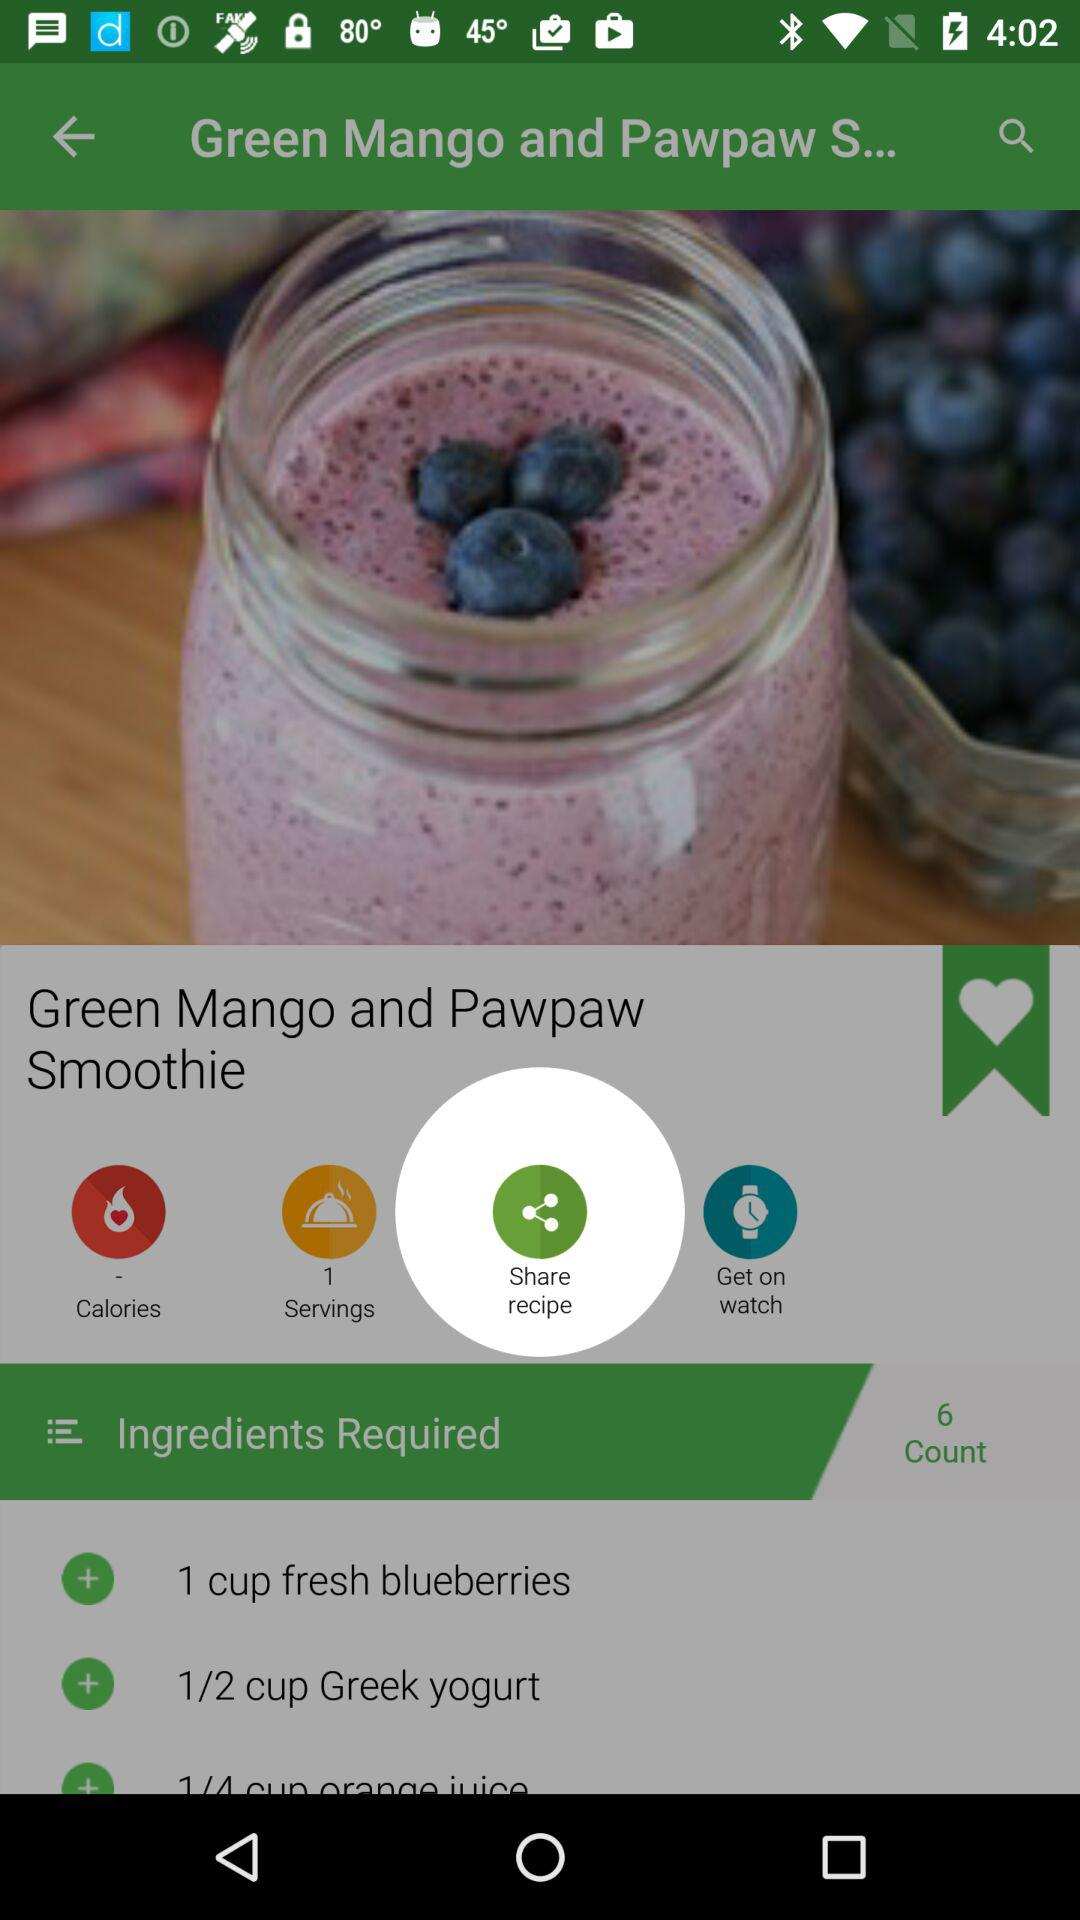What is the name of the smoothie? The name of the smoothie is "Green Mango and Pawpaw Smoothie". 